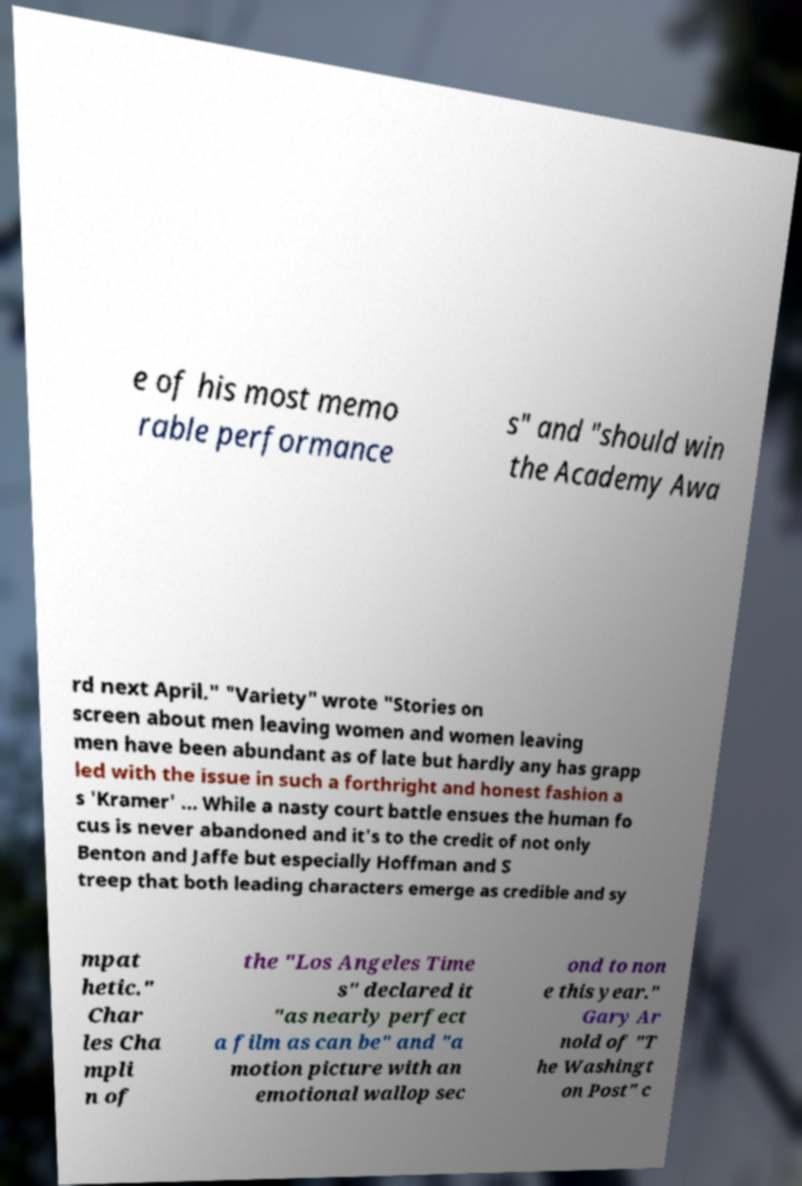Please identify and transcribe the text found in this image. e of his most memo rable performance s" and "should win the Academy Awa rd next April." "Variety" wrote "Stories on screen about men leaving women and women leaving men have been abundant as of late but hardly any has grapp led with the issue in such a forthright and honest fashion a s 'Kramer' ... While a nasty court battle ensues the human fo cus is never abandoned and it's to the credit of not only Benton and Jaffe but especially Hoffman and S treep that both leading characters emerge as credible and sy mpat hetic." Char les Cha mpli n of the "Los Angeles Time s" declared it "as nearly perfect a film as can be" and "a motion picture with an emotional wallop sec ond to non e this year." Gary Ar nold of "T he Washingt on Post" c 